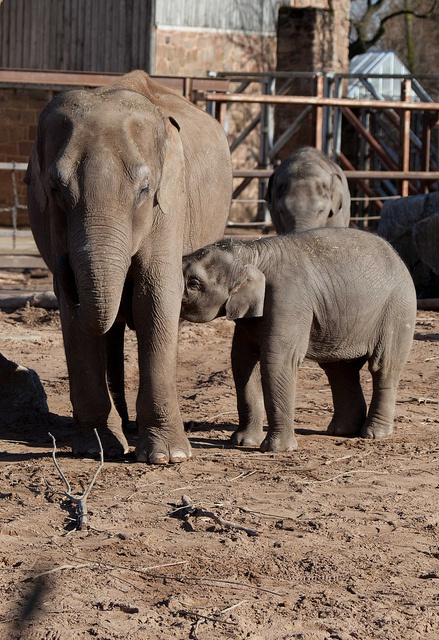Describe the objects in this image and their specific colors. I can see elephant in tan, black, and gray tones, elephant in tan, black, darkgray, and gray tones, elephant in tan, black, gray, and darkgray tones, and elephant in tan, black, darkgray, and gray tones in this image. 